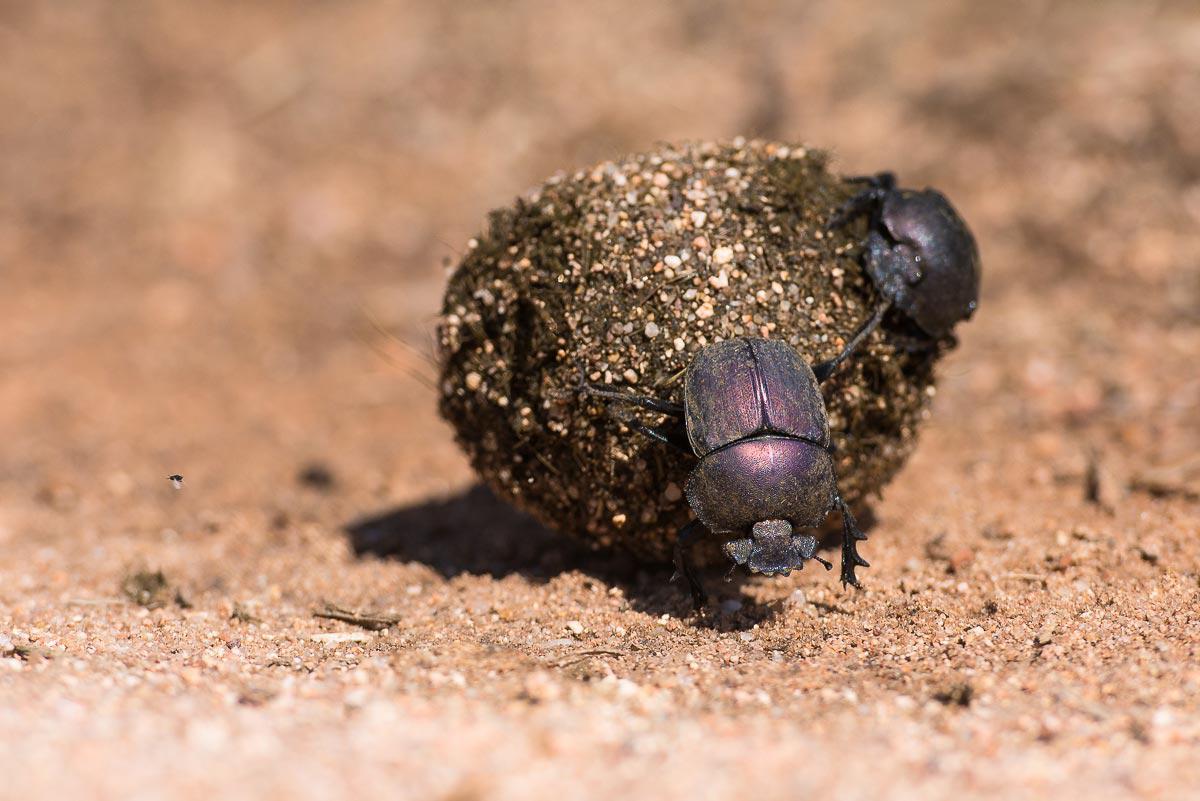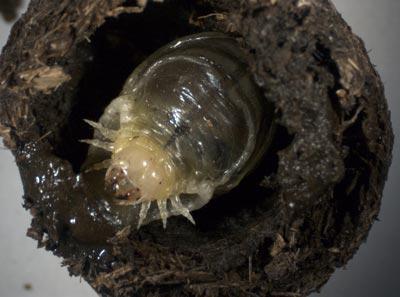The first image is the image on the left, the second image is the image on the right. Analyze the images presented: Is the assertion "An image shows a dungball with two beetles on it, and one beetle has no part touching the ground." valid? Answer yes or no. Yes. The first image is the image on the left, the second image is the image on the right. Considering the images on both sides, is "There are two beetles on the clod of dirt in the image on the right." valid? Answer yes or no. No. 